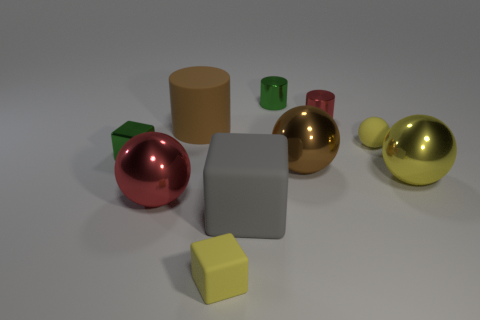Subtract all yellow balls. How many were subtracted if there are1yellow balls left? 1 Subtract all spheres. How many objects are left? 6 Add 7 small red cylinders. How many small red cylinders exist? 8 Subtract 0 red cubes. How many objects are left? 10 Subtract all tiny purple shiny spheres. Subtract all red cylinders. How many objects are left? 9 Add 2 gray objects. How many gray objects are left? 3 